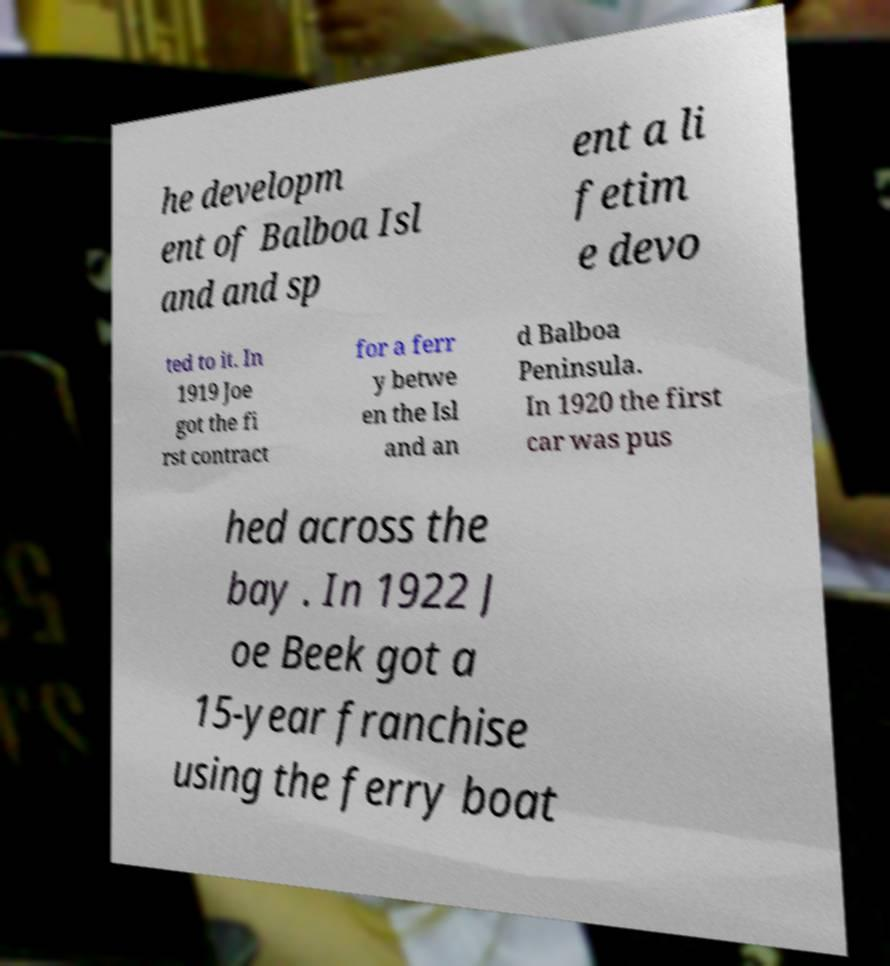I need the written content from this picture converted into text. Can you do that? he developm ent of Balboa Isl and and sp ent a li fetim e devo ted to it. In 1919 Joe got the fi rst contract for a ferr y betwe en the Isl and an d Balboa Peninsula. In 1920 the first car was pus hed across the bay . In 1922 J oe Beek got a 15-year franchise using the ferry boat 